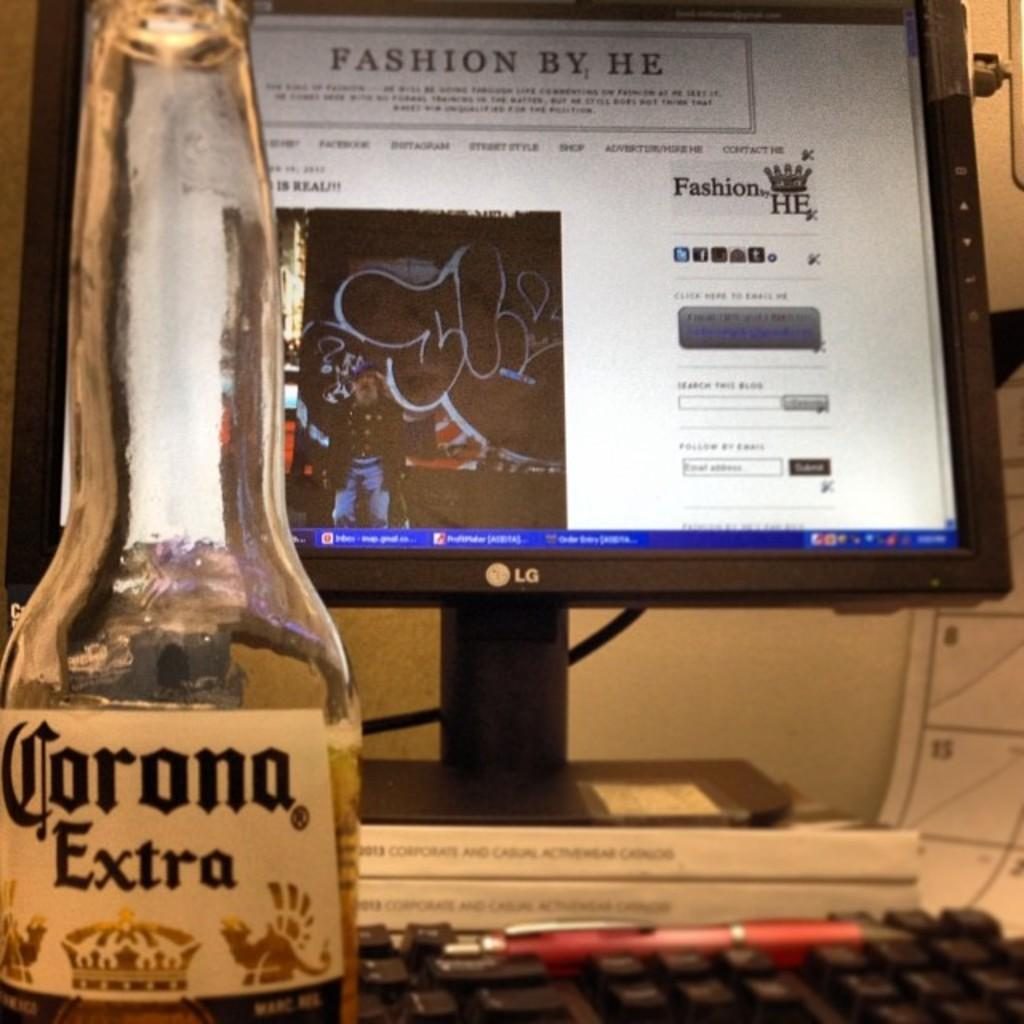<image>
Provide a brief description of the given image. The alcohol on the table is labeled Corona Extra 